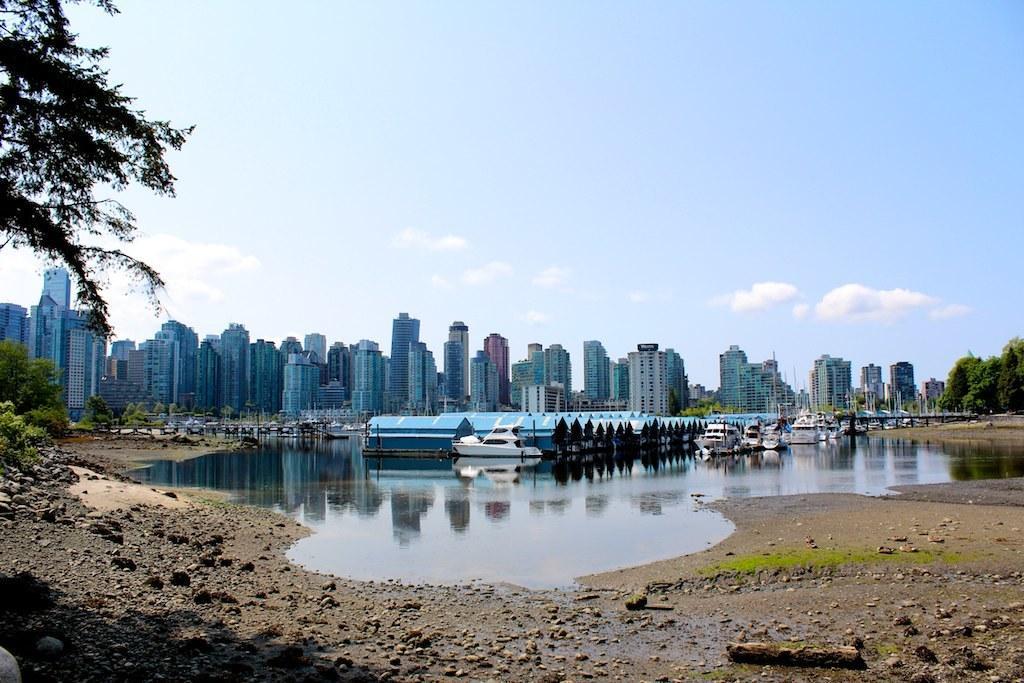Please provide a concise description of this image. At the bottom of the image there is water and grass. Above the water there are some ships. In the middle of the image there are some trees and buildings. At the top of the image there are some clouds and sky. 